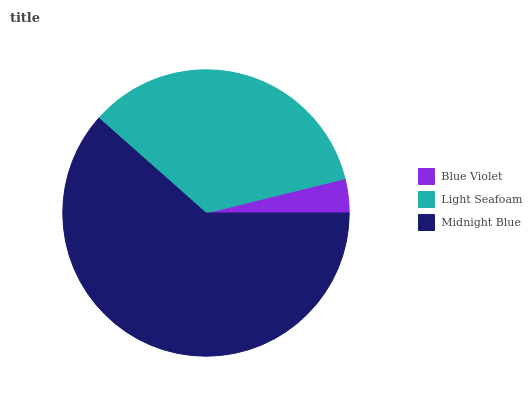Is Blue Violet the minimum?
Answer yes or no. Yes. Is Midnight Blue the maximum?
Answer yes or no. Yes. Is Light Seafoam the minimum?
Answer yes or no. No. Is Light Seafoam the maximum?
Answer yes or no. No. Is Light Seafoam greater than Blue Violet?
Answer yes or no. Yes. Is Blue Violet less than Light Seafoam?
Answer yes or no. Yes. Is Blue Violet greater than Light Seafoam?
Answer yes or no. No. Is Light Seafoam less than Blue Violet?
Answer yes or no. No. Is Light Seafoam the high median?
Answer yes or no. Yes. Is Light Seafoam the low median?
Answer yes or no. Yes. Is Blue Violet the high median?
Answer yes or no. No. Is Midnight Blue the low median?
Answer yes or no. No. 